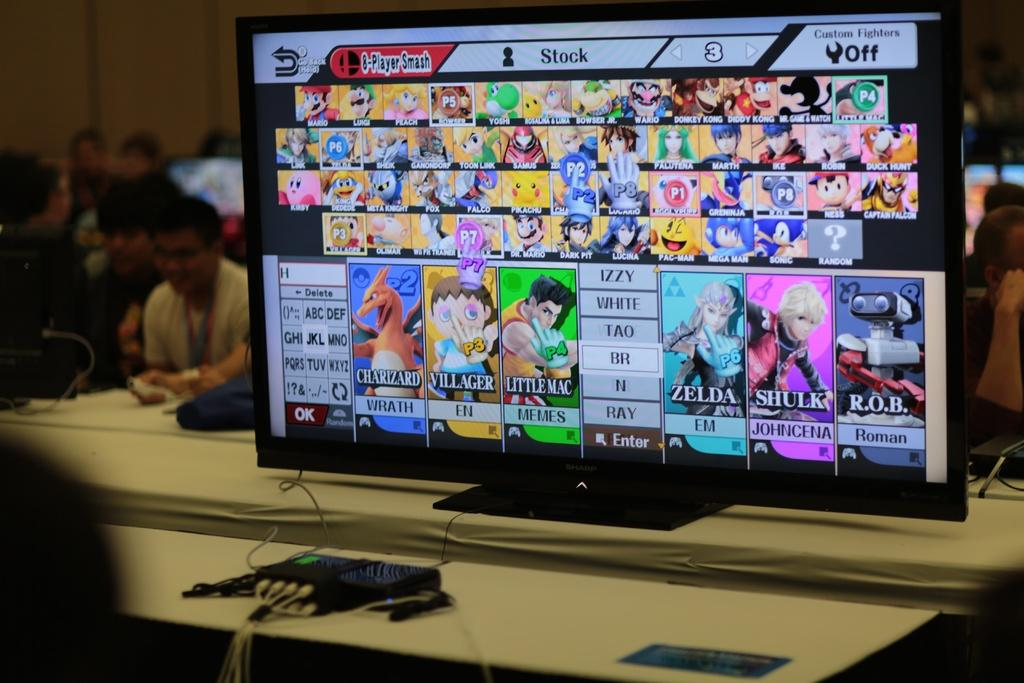<image>
Provide a brief description of the given image. On the upper right corner of the monitor it appears that custom fighters has been turned off. 